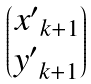<formula> <loc_0><loc_0><loc_500><loc_500>\begin{pmatrix} { x ^ { \prime } } _ { k + 1 } \\ { y ^ { \prime } } _ { k + 1 } \end{pmatrix}</formula> 